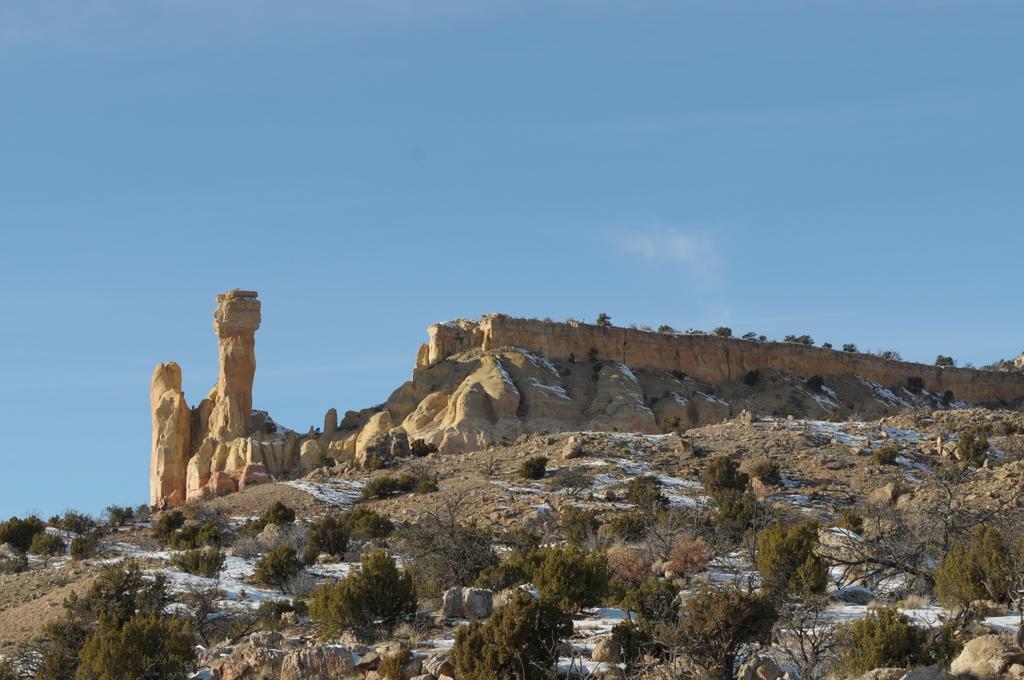How would you summarize this image in a sentence or two? In this picture I can see trees, rocks, and in the background there is sky. 